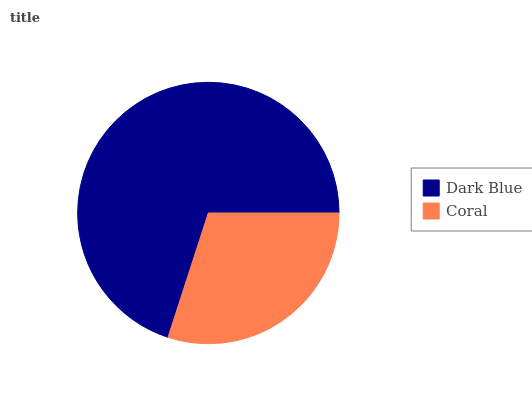Is Coral the minimum?
Answer yes or no. Yes. Is Dark Blue the maximum?
Answer yes or no. Yes. Is Coral the maximum?
Answer yes or no. No. Is Dark Blue greater than Coral?
Answer yes or no. Yes. Is Coral less than Dark Blue?
Answer yes or no. Yes. Is Coral greater than Dark Blue?
Answer yes or no. No. Is Dark Blue less than Coral?
Answer yes or no. No. Is Dark Blue the high median?
Answer yes or no. Yes. Is Coral the low median?
Answer yes or no. Yes. Is Coral the high median?
Answer yes or no. No. Is Dark Blue the low median?
Answer yes or no. No. 